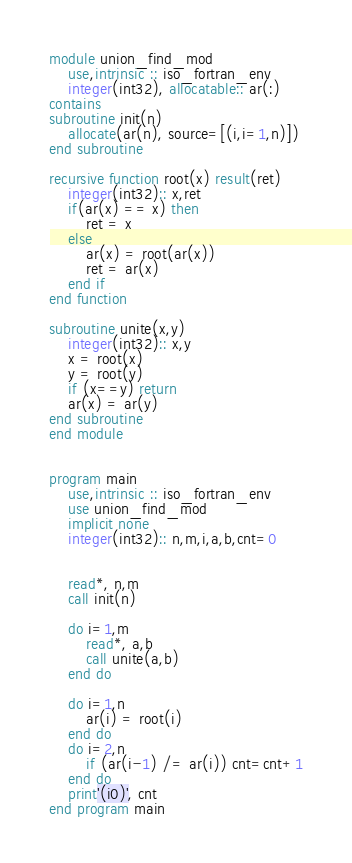Convert code to text. <code><loc_0><loc_0><loc_500><loc_500><_FORTRAN_>module union_find_mod
    use,intrinsic :: iso_fortran_env
    integer(int32), allocatable:: ar(:)
contains
subroutine init(n)
    allocate(ar(n), source=[(i,i=1,n)])
end subroutine

recursive function root(x) result(ret)
    integer(int32):: x,ret
    if(ar(x) == x) then
        ret = x
    else
        ar(x) = root(ar(x))
        ret = ar(x)
    end if
end function

subroutine unite(x,y)
    integer(int32):: x,y
    x = root(x)
    y = root(y)
    if (x==y) return
    ar(x) = ar(y)
end subroutine
end module


program main
    use,intrinsic :: iso_fortran_env
    use union_find_mod
    implicit none
    integer(int32):: n,m,i,a,b,cnt=0


    read*, n,m
    call init(n)

    do i=1,m
        read*, a,b
        call unite(a,b)
    end do

    do i=1,n
        ar(i) = root(i)
    end do
    do i=2,n
        if (ar(i-1) /= ar(i)) cnt=cnt+1
    end do
    print'(i0)', cnt
end program main</code> 